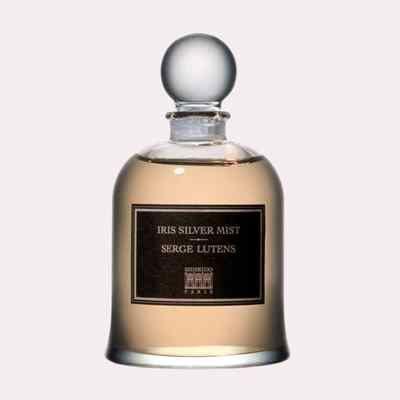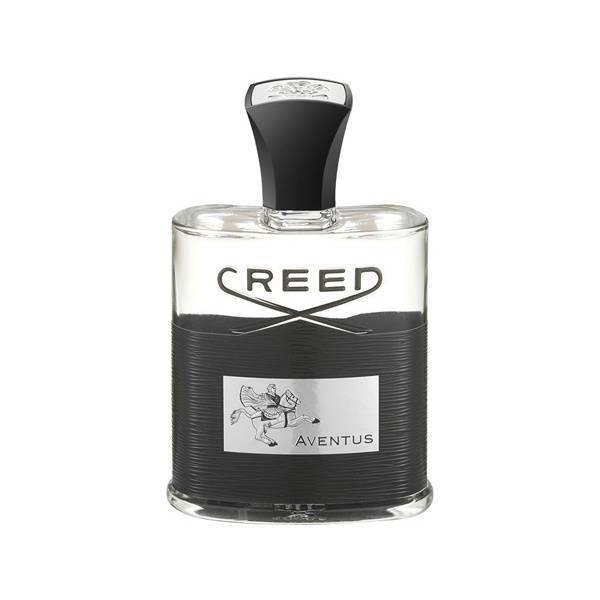The first image is the image on the left, the second image is the image on the right. Given the left and right images, does the statement "One image shows a fragrance bottle of brown liquid with a black label and a glass-look cap shaped somewhat like a T." hold true? Answer yes or no. No. The first image is the image on the left, the second image is the image on the right. Given the left and right images, does the statement "There is a bottle of perfume being displayed in the center of each image." hold true? Answer yes or no. Yes. 